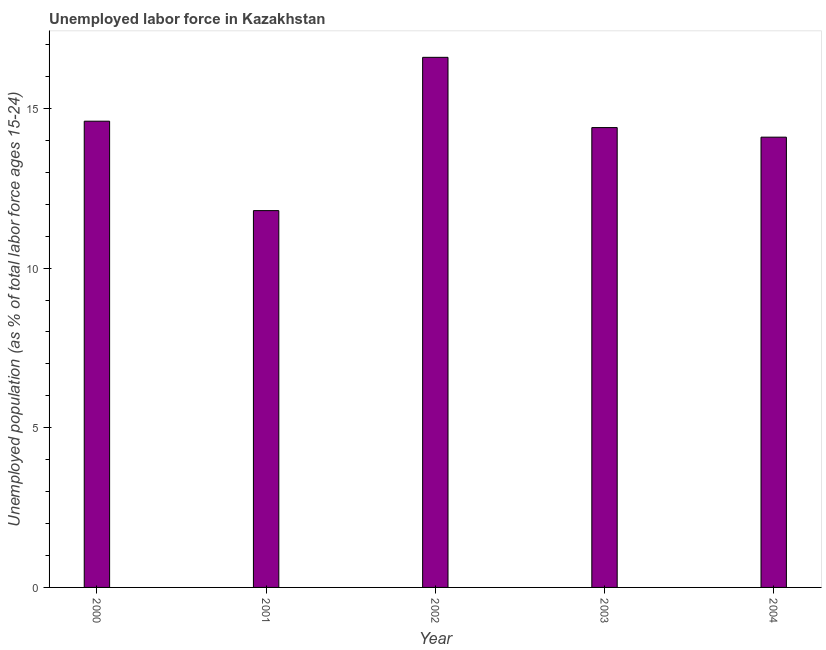What is the title of the graph?
Offer a very short reply. Unemployed labor force in Kazakhstan. What is the label or title of the X-axis?
Ensure brevity in your answer.  Year. What is the label or title of the Y-axis?
Ensure brevity in your answer.  Unemployed population (as % of total labor force ages 15-24). What is the total unemployed youth population in 2001?
Your response must be concise. 11.8. Across all years, what is the maximum total unemployed youth population?
Your response must be concise. 16.6. Across all years, what is the minimum total unemployed youth population?
Give a very brief answer. 11.8. In which year was the total unemployed youth population minimum?
Offer a very short reply. 2001. What is the sum of the total unemployed youth population?
Give a very brief answer. 71.5. What is the average total unemployed youth population per year?
Provide a short and direct response. 14.3. What is the median total unemployed youth population?
Provide a succinct answer. 14.4. What is the ratio of the total unemployed youth population in 2000 to that in 2004?
Your answer should be compact. 1.03. Is the total unemployed youth population in 2002 less than that in 2003?
Keep it short and to the point. No. In how many years, is the total unemployed youth population greater than the average total unemployed youth population taken over all years?
Keep it short and to the point. 3. How many bars are there?
Your answer should be very brief. 5. How many years are there in the graph?
Make the answer very short. 5. What is the difference between two consecutive major ticks on the Y-axis?
Ensure brevity in your answer.  5. What is the Unemployed population (as % of total labor force ages 15-24) in 2000?
Offer a very short reply. 14.6. What is the Unemployed population (as % of total labor force ages 15-24) of 2001?
Ensure brevity in your answer.  11.8. What is the Unemployed population (as % of total labor force ages 15-24) of 2002?
Ensure brevity in your answer.  16.6. What is the Unemployed population (as % of total labor force ages 15-24) of 2003?
Keep it short and to the point. 14.4. What is the Unemployed population (as % of total labor force ages 15-24) of 2004?
Offer a terse response. 14.1. What is the difference between the Unemployed population (as % of total labor force ages 15-24) in 2000 and 2002?
Your answer should be very brief. -2. What is the difference between the Unemployed population (as % of total labor force ages 15-24) in 2000 and 2003?
Your answer should be very brief. 0.2. What is the difference between the Unemployed population (as % of total labor force ages 15-24) in 2001 and 2004?
Provide a succinct answer. -2.3. What is the difference between the Unemployed population (as % of total labor force ages 15-24) in 2002 and 2003?
Provide a short and direct response. 2.2. What is the ratio of the Unemployed population (as % of total labor force ages 15-24) in 2000 to that in 2001?
Your response must be concise. 1.24. What is the ratio of the Unemployed population (as % of total labor force ages 15-24) in 2000 to that in 2002?
Make the answer very short. 0.88. What is the ratio of the Unemployed population (as % of total labor force ages 15-24) in 2000 to that in 2004?
Give a very brief answer. 1.03. What is the ratio of the Unemployed population (as % of total labor force ages 15-24) in 2001 to that in 2002?
Offer a very short reply. 0.71. What is the ratio of the Unemployed population (as % of total labor force ages 15-24) in 2001 to that in 2003?
Your answer should be very brief. 0.82. What is the ratio of the Unemployed population (as % of total labor force ages 15-24) in 2001 to that in 2004?
Your answer should be compact. 0.84. What is the ratio of the Unemployed population (as % of total labor force ages 15-24) in 2002 to that in 2003?
Your answer should be compact. 1.15. What is the ratio of the Unemployed population (as % of total labor force ages 15-24) in 2002 to that in 2004?
Offer a terse response. 1.18. 